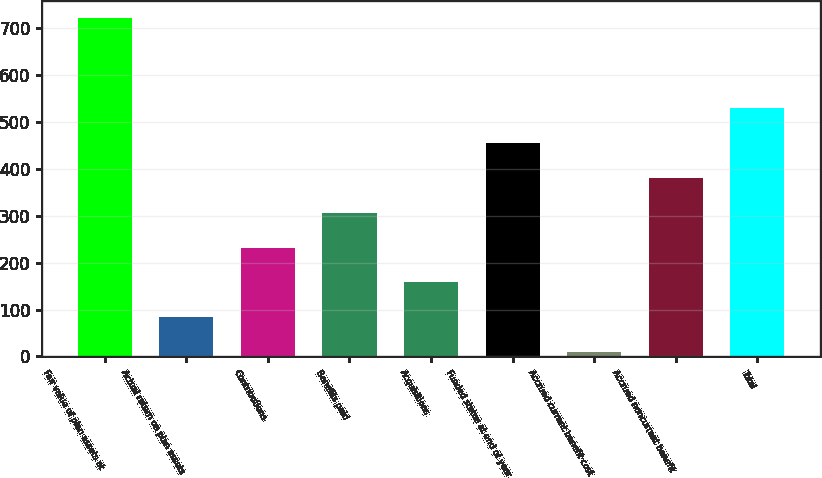Convert chart. <chart><loc_0><loc_0><loc_500><loc_500><bar_chart><fcel>Fair value of plan assets at<fcel>Actual return on plan assets<fcel>Contributions<fcel>Benefits paid<fcel>Acquisitions<fcel>Funded status at end of year<fcel>Accrued current benefit cost<fcel>Accrued noncurrent benefit<fcel>Total<nl><fcel>722.9<fcel>83.84<fcel>232.32<fcel>306.56<fcel>158.08<fcel>455.04<fcel>9.6<fcel>380.8<fcel>529.28<nl></chart> 